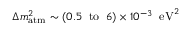Convert formula to latex. <formula><loc_0><loc_0><loc_500><loc_500>\Delta m _ { a t m } ^ { 2 } \sim ( 0 . 5 \, t o \, 6 ) \times 1 0 ^ { - 3 } \, e V ^ { 2 }</formula> 